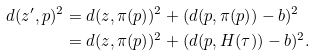<formula> <loc_0><loc_0><loc_500><loc_500>d ( z ^ { \prime } , p ) ^ { 2 } & = d ( z , \pi ( p ) ) ^ { 2 } + ( d ( p , \pi ( p ) ) - b ) ^ { 2 } \\ & = d ( z , \pi ( p ) ) ^ { 2 } + ( d ( p , H ( \tau ) ) - b ) ^ { 2 } .</formula> 